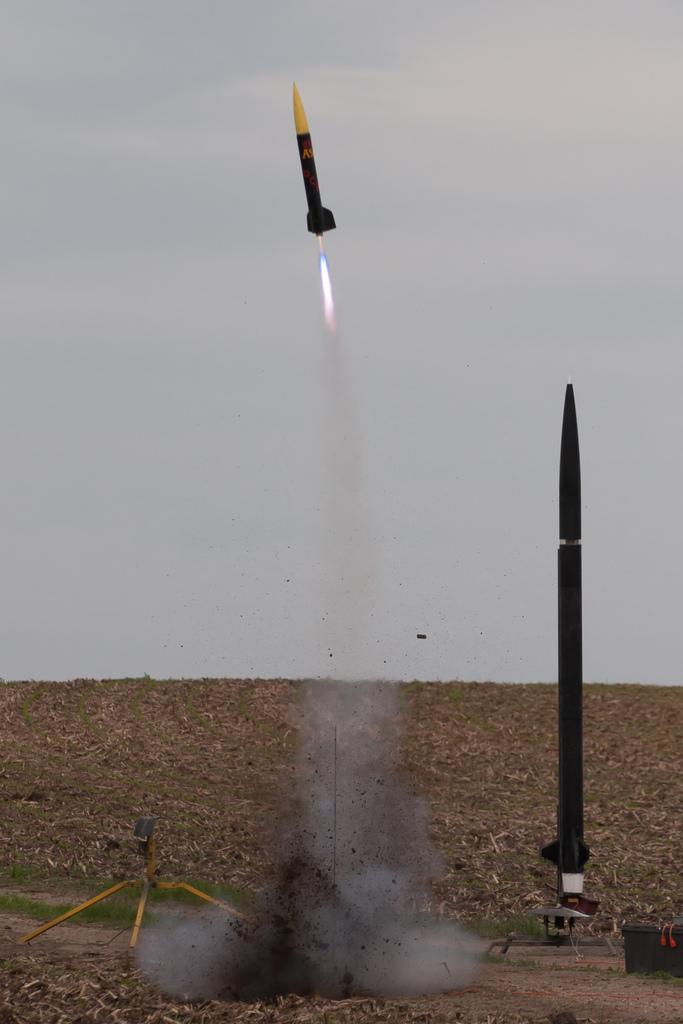What is located in the center of the image? There is a stand in the center of the image. What type of objects can be seen near the stand? There are rockets in the image. What other object is present in the image? There is a box in the image. Can you describe the background of the image? The sky, clouds, and grass are visible in the background of the image. How many types of objects are present in the image? There are at least four types of objects present in the image: a stand, rockets, a box, and other unspecified objects. What type of competition is taking place in the image? There is no competition present in the image; it features a stand, rockets, a box, and other unspecified objects. What sound does the horn make in the image? There is no horn present in the image. 